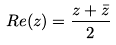<formula> <loc_0><loc_0><loc_500><loc_500>R e ( z ) = { \frac { z + { \bar { z } } } { 2 } }</formula> 